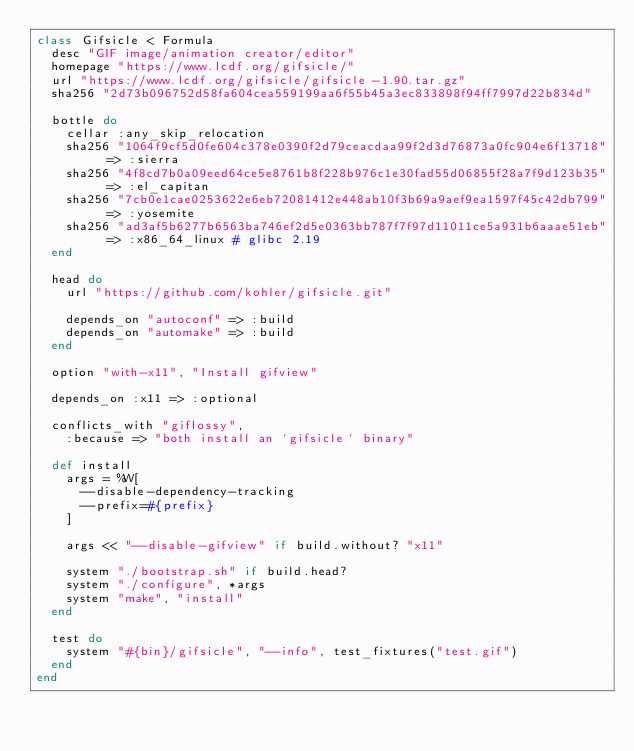Convert code to text. <code><loc_0><loc_0><loc_500><loc_500><_Ruby_>class Gifsicle < Formula
  desc "GIF image/animation creator/editor"
  homepage "https://www.lcdf.org/gifsicle/"
  url "https://www.lcdf.org/gifsicle/gifsicle-1.90.tar.gz"
  sha256 "2d73b096752d58fa604cea559199aa6f55b45a3ec833898f94ff7997d22b834d"

  bottle do
    cellar :any_skip_relocation
    sha256 "1064f9cf5d0fe604c378e0390f2d79ceacdaa99f2d3d76873a0fc904e6f13718" => :sierra
    sha256 "4f8cd7b0a09eed64ce5e8761b8f228b976c1e30fad55d06855f28a7f9d123b35" => :el_capitan
    sha256 "7cb0e1cae0253622e6eb72081412e448ab10f3b69a9aef9ea1597f45c42db799" => :yosemite
    sha256 "ad3af5b6277b6563ba746ef2d5e0363bb787f7f97d11011ce5a931b6aaae51eb" => :x86_64_linux # glibc 2.19
  end

  head do
    url "https://github.com/kohler/gifsicle.git"

    depends_on "autoconf" => :build
    depends_on "automake" => :build
  end

  option "with-x11", "Install gifview"

  depends_on :x11 => :optional

  conflicts_with "giflossy",
    :because => "both install an `gifsicle` binary"

  def install
    args = %W[
      --disable-dependency-tracking
      --prefix=#{prefix}
    ]

    args << "--disable-gifview" if build.without? "x11"

    system "./bootstrap.sh" if build.head?
    system "./configure", *args
    system "make", "install"
  end

  test do
    system "#{bin}/gifsicle", "--info", test_fixtures("test.gif")
  end
end
</code> 